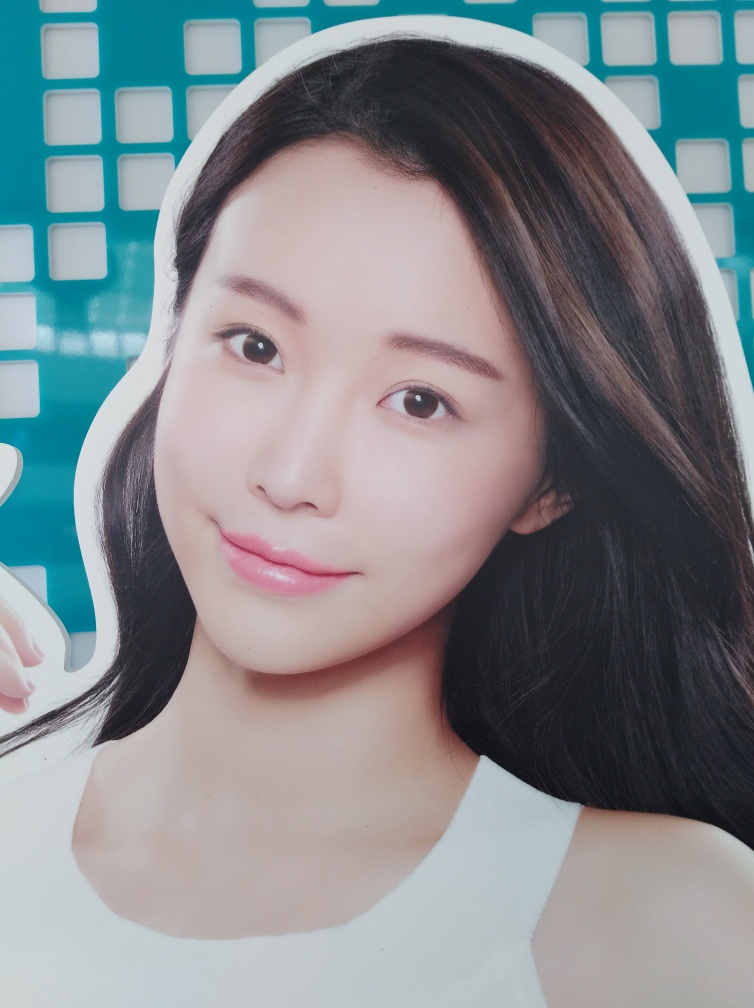Are there any quality issues with this image? The image is quite clear and well-lit, with no evident pixelation or blurring. However, the context in which the image is taken or its end use can't be determined from the provided information, which limits the ability to fully evaluate quality for specific needs. 